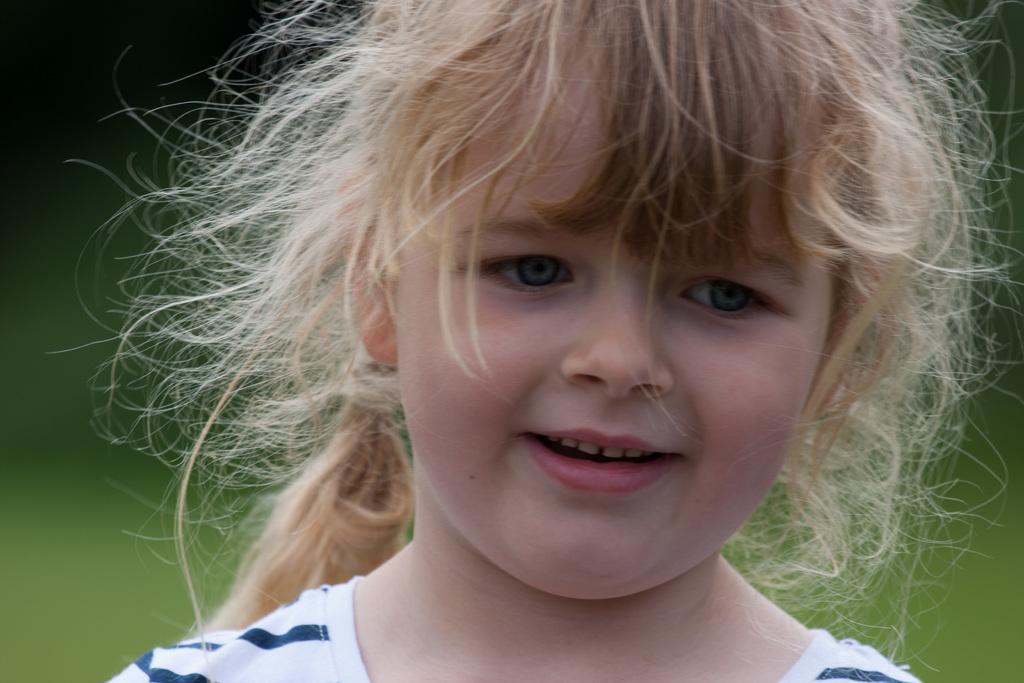Who is the main subject in the image? There is a girl in the image. What is the girl wearing? The girl is wearing a white and blue striped dress. What expression does the girl have? The girl is smiling. What color are the girl's eyes? The girl has blue eyes. Can you describe the background of the image? The background of the image is blurry. How many jellyfish can be seen swimming in the background of the image? There are no jellyfish present in the image; the background is blurry. What type of horse is standing next to the girl in the image? There is no horse present in the image; the main subject is the girl. 